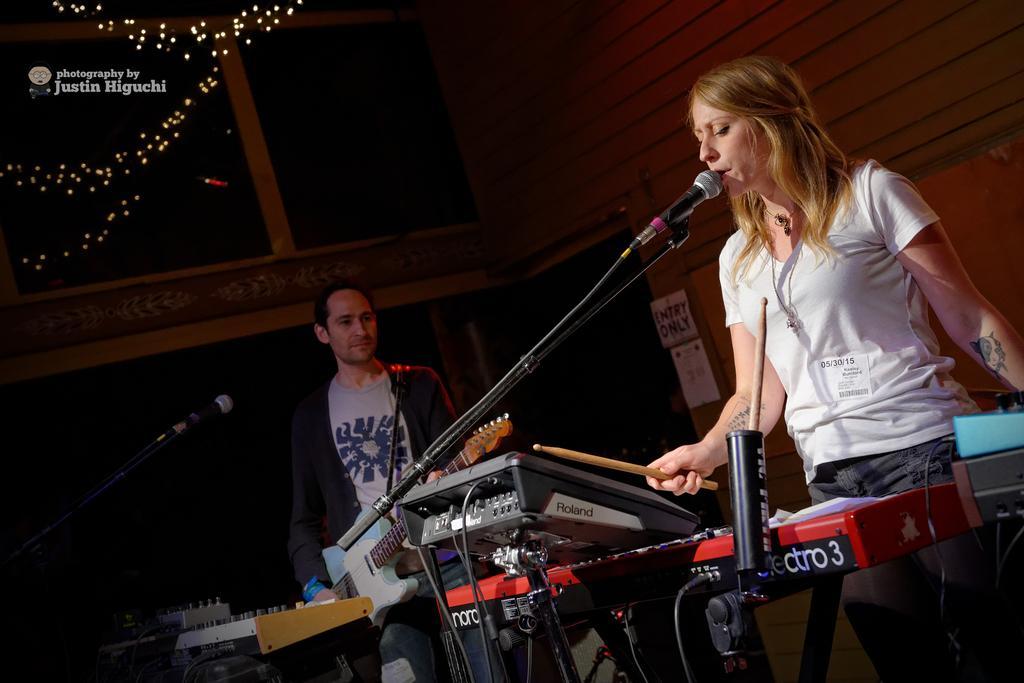In one or two sentences, can you explain what this image depicts? In this image we can see two persons standing and playing musical instruments, there are mics in front of them, there are posters attached to the wall and there are lights on the left side of the image. 